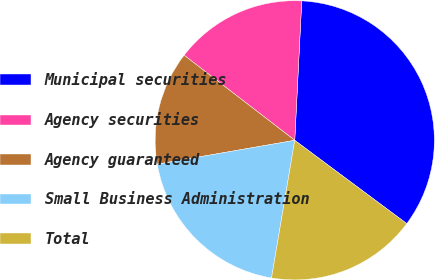<chart> <loc_0><loc_0><loc_500><loc_500><pie_chart><fcel>Municipal securities<fcel>Agency securities<fcel>Agency guaranteed<fcel>Small Business Administration<fcel>Total<nl><fcel>34.38%<fcel>15.36%<fcel>13.17%<fcel>19.6%<fcel>17.48%<nl></chart> 